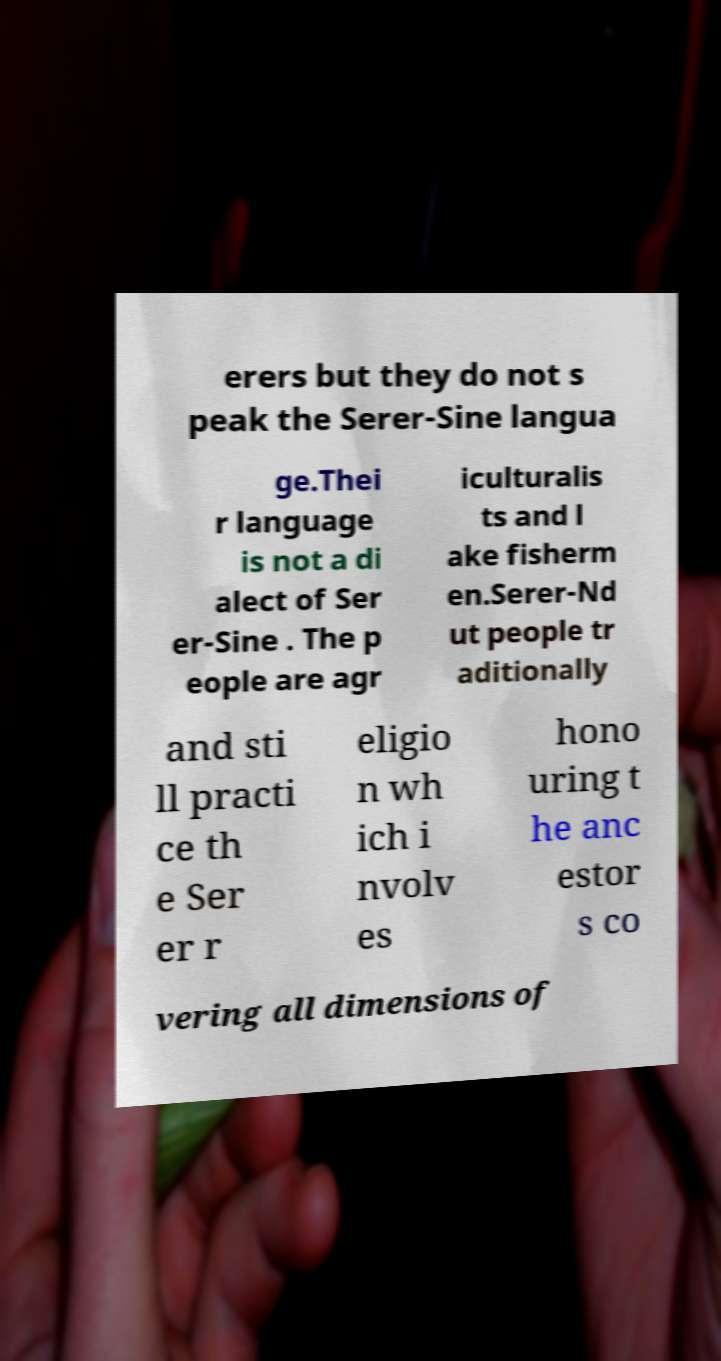Please read and relay the text visible in this image. What does it say? erers but they do not s peak the Serer-Sine langua ge.Thei r language is not a di alect of Ser er-Sine . The p eople are agr iculturalis ts and l ake fisherm en.Serer-Nd ut people tr aditionally and sti ll practi ce th e Ser er r eligio n wh ich i nvolv es hono uring t he anc estor s co vering all dimensions of 